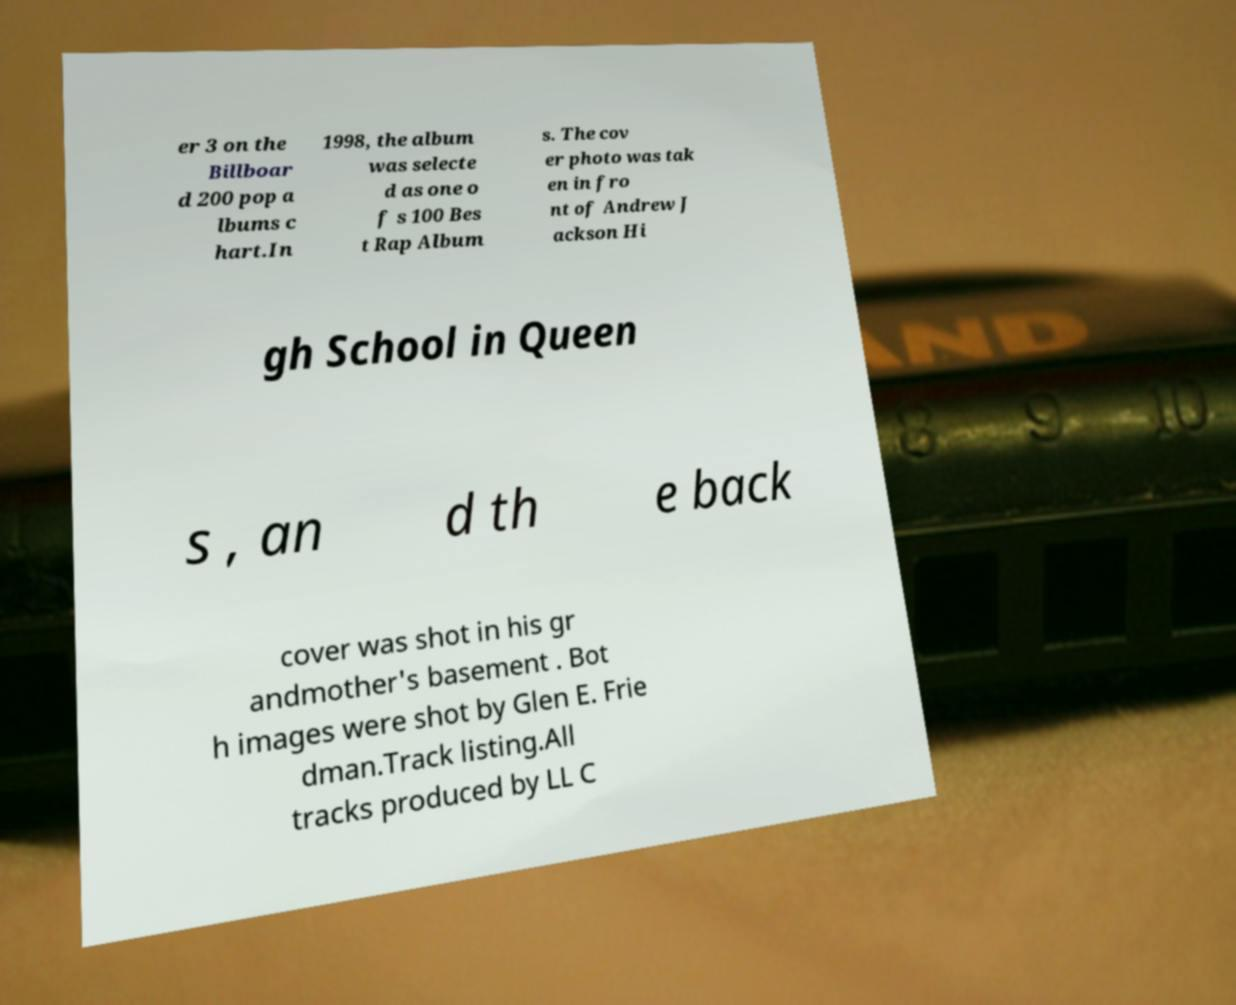Can you read and provide the text displayed in the image?This photo seems to have some interesting text. Can you extract and type it out for me? er 3 on the Billboar d 200 pop a lbums c hart.In 1998, the album was selecte d as one o f s 100 Bes t Rap Album s. The cov er photo was tak en in fro nt of Andrew J ackson Hi gh School in Queen s , an d th e back cover was shot in his gr andmother's basement . Bot h images were shot by Glen E. Frie dman.Track listing.All tracks produced by LL C 